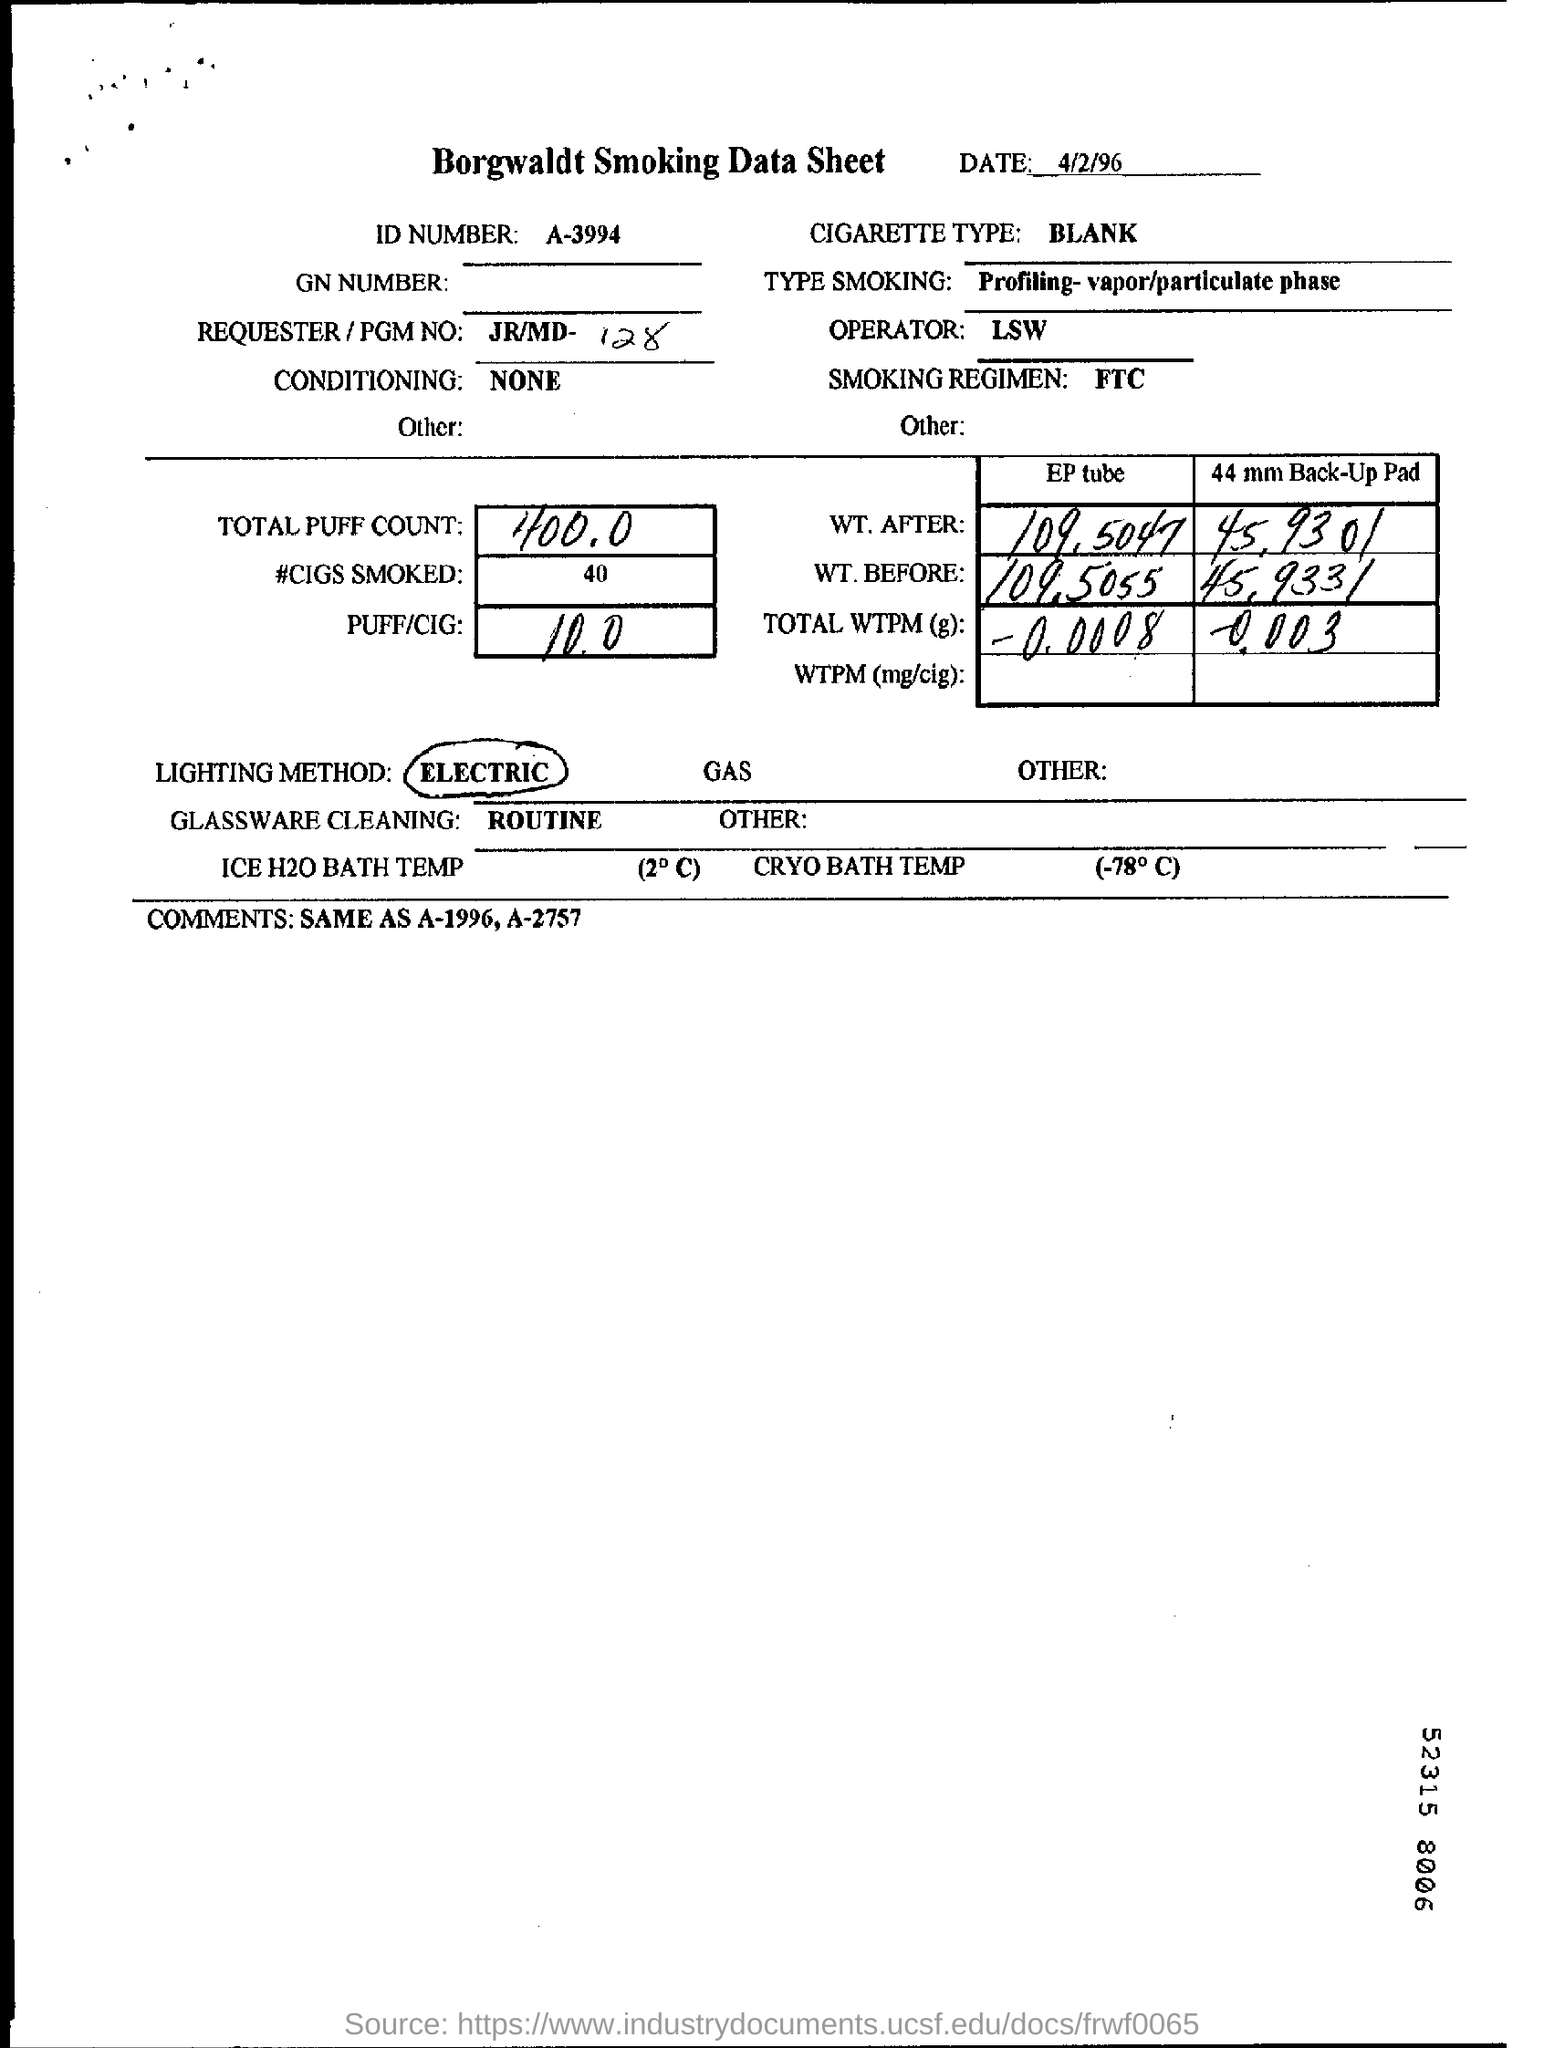Identify some key points in this picture. The document contains the ID number A-3994.. The date mentioned at the top of the document is 4/2/96. The document in question is titled "Borgwaldt Smoking Data Sheet. The application of any type of conditioning has not been reported or observed. The Type Smoking field indicates that the sampling location was profiled for both the vapor and particulate phase during the sampling process. 